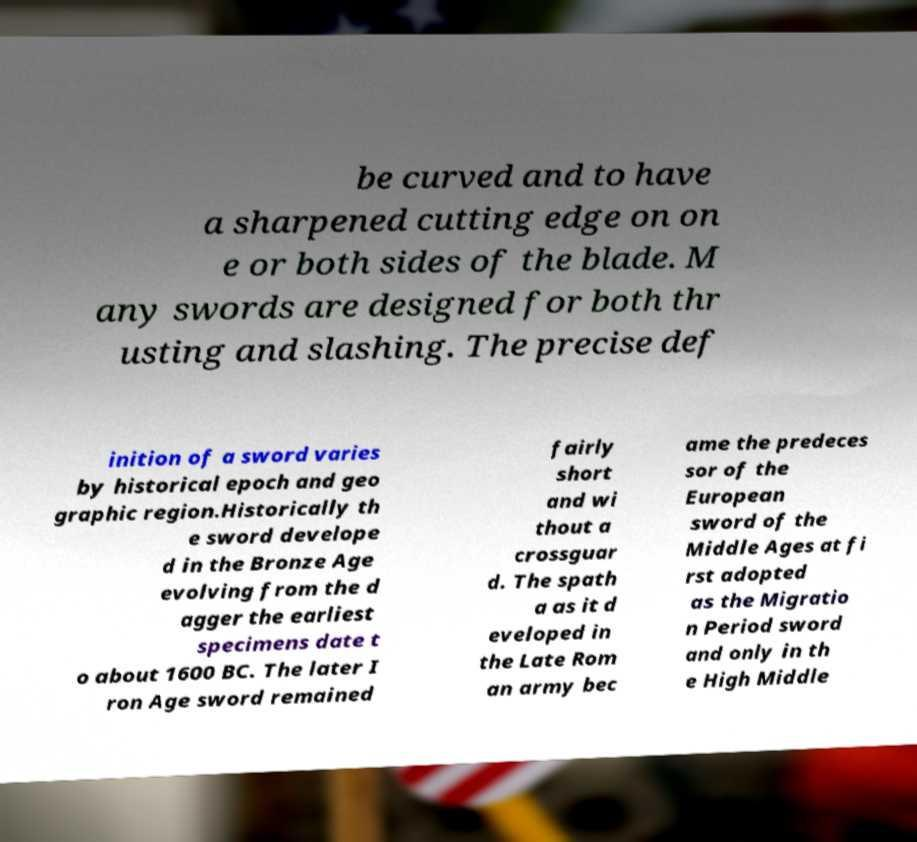Can you read and provide the text displayed in the image?This photo seems to have some interesting text. Can you extract and type it out for me? be curved and to have a sharpened cutting edge on on e or both sides of the blade. M any swords are designed for both thr usting and slashing. The precise def inition of a sword varies by historical epoch and geo graphic region.Historically th e sword develope d in the Bronze Age evolving from the d agger the earliest specimens date t o about 1600 BC. The later I ron Age sword remained fairly short and wi thout a crossguar d. The spath a as it d eveloped in the Late Rom an army bec ame the predeces sor of the European sword of the Middle Ages at fi rst adopted as the Migratio n Period sword and only in th e High Middle 